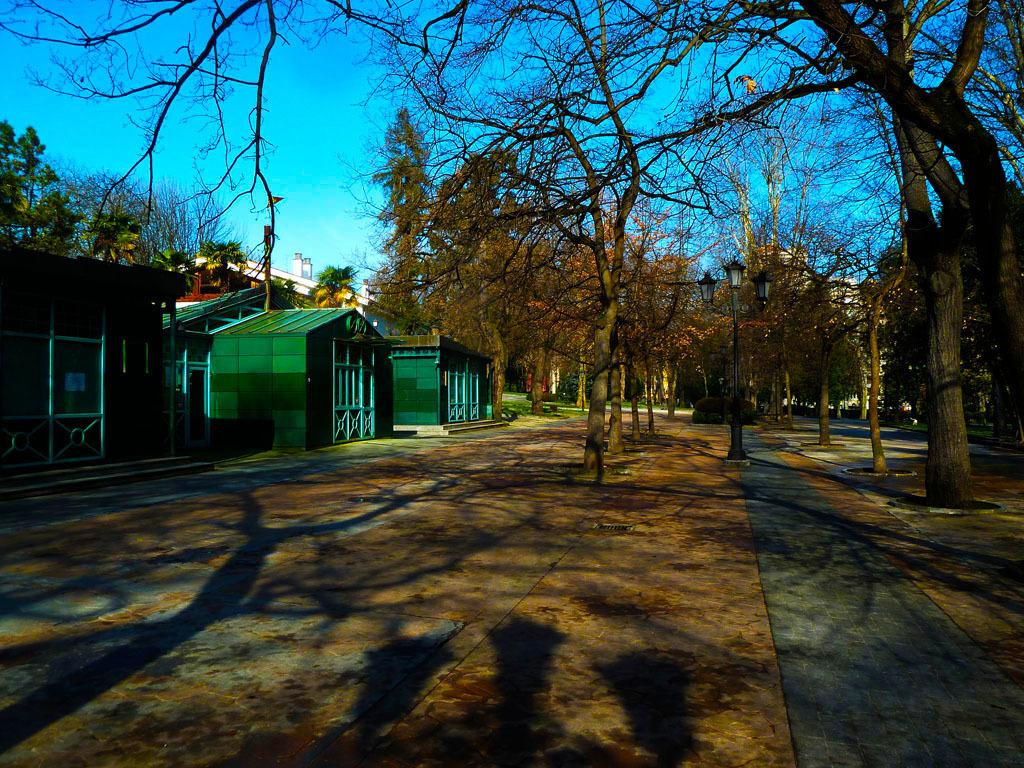What type of structures can be seen in the image? There are houses in the image. What type of vegetation is present in the image? There are trees and plants in the image. What object can be seen standing upright in the image? There is a pole in the image. What type of illumination is present in the image? There are lights in the image. What can be seen in the background of the image? The sky is visible in the background of the image. What type of voice can be heard coming from the pole in the image? There is no voice coming from the pole in the image, as it is an inanimate object. What type of trick is being performed by the trees in the image? There is no trick being performed by the trees in the image; they are simply standing in their natural state. 